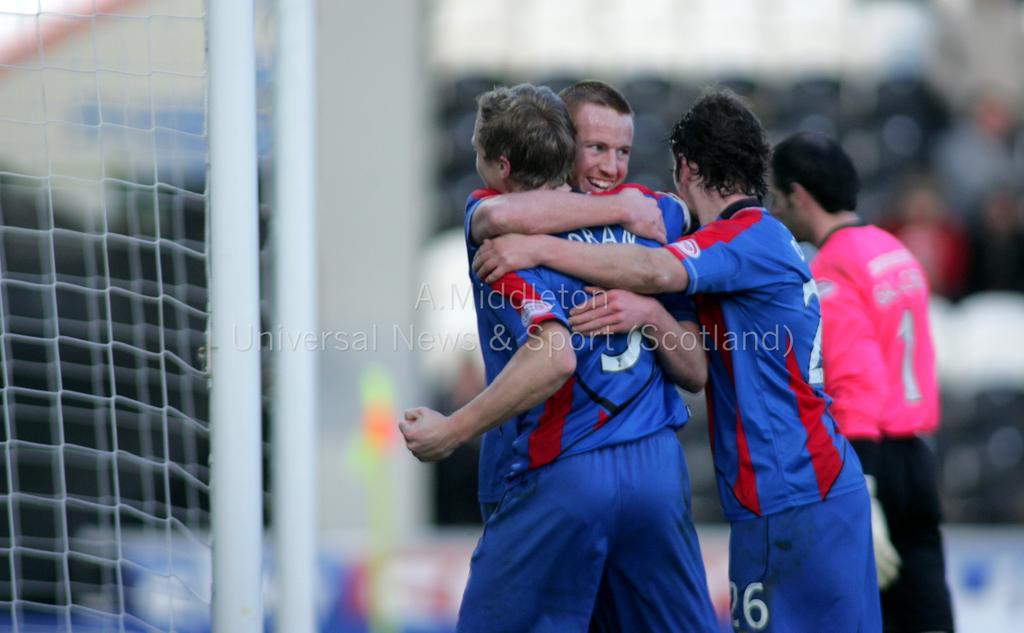What number is the man in the red jersey?
Your answer should be compact. 1. What is the right blue player's number?
Your answer should be very brief. 26. 